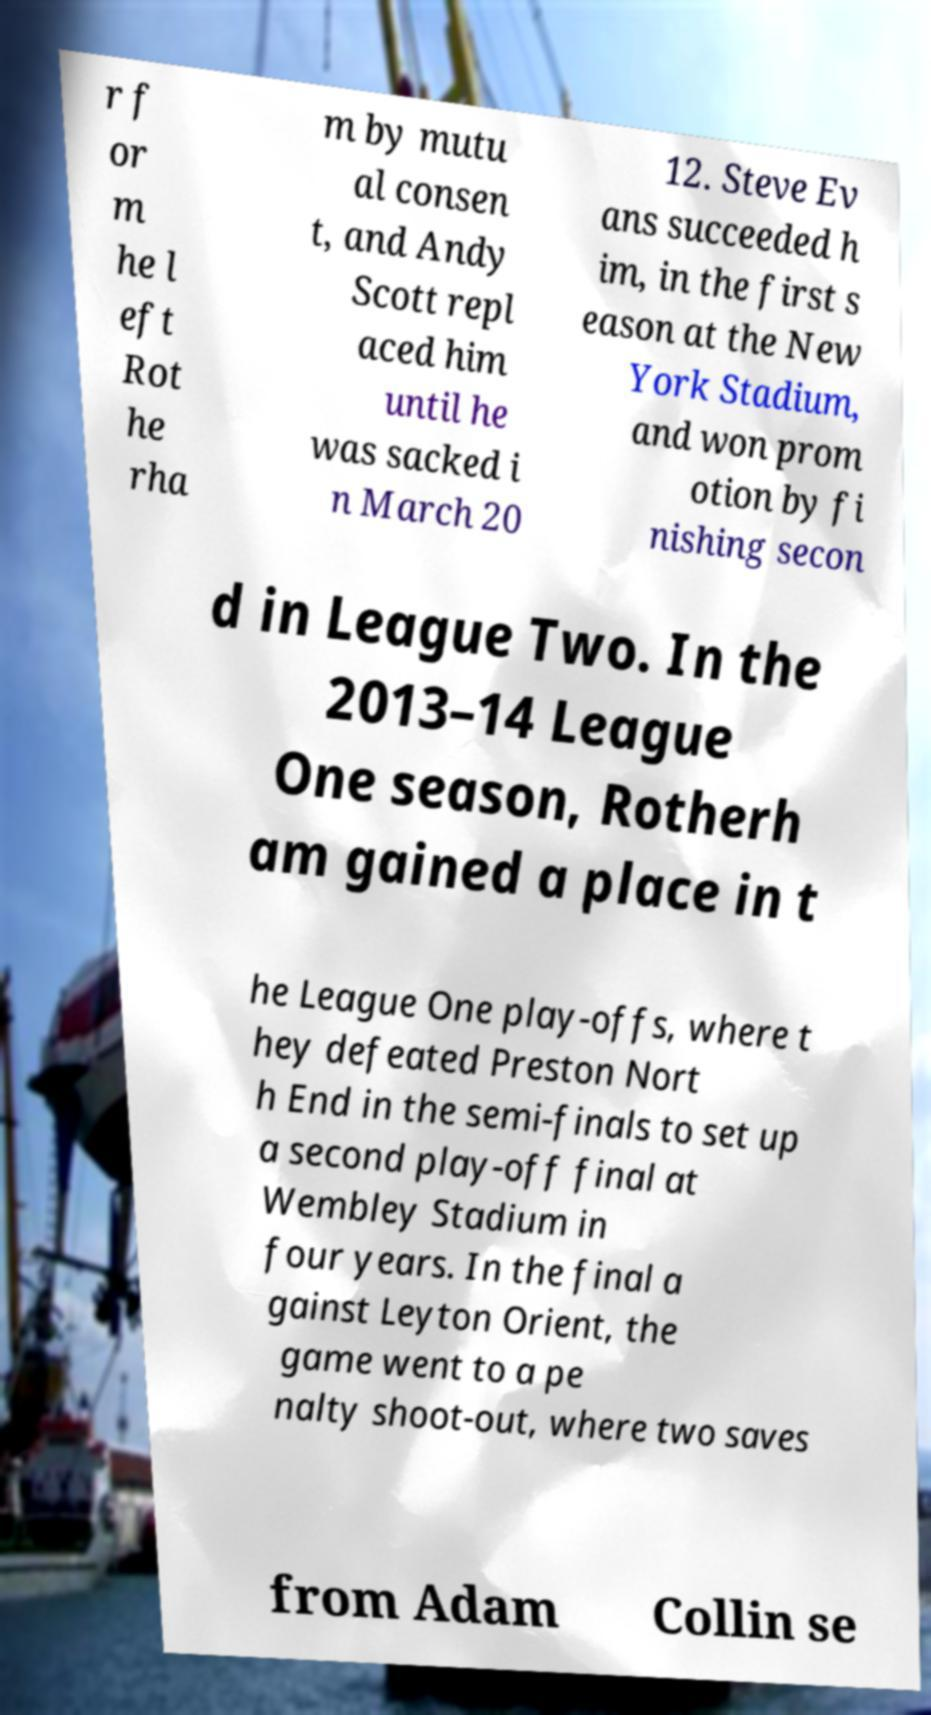Could you assist in decoding the text presented in this image and type it out clearly? r f or m he l eft Rot he rha m by mutu al consen t, and Andy Scott repl aced him until he was sacked i n March 20 12. Steve Ev ans succeeded h im, in the first s eason at the New York Stadium, and won prom otion by fi nishing secon d in League Two. In the 2013–14 League One season, Rotherh am gained a place in t he League One play-offs, where t hey defeated Preston Nort h End in the semi-finals to set up a second play-off final at Wembley Stadium in four years. In the final a gainst Leyton Orient, the game went to a pe nalty shoot-out, where two saves from Adam Collin se 